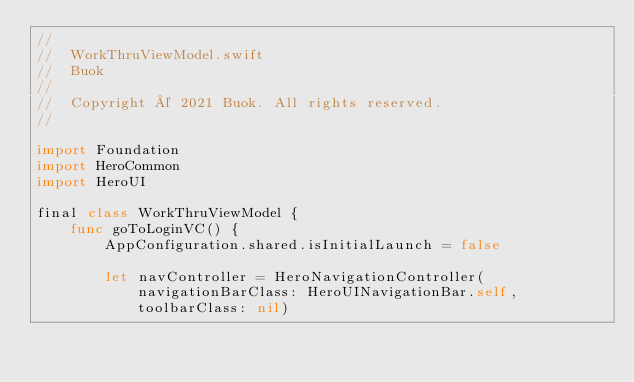<code> <loc_0><loc_0><loc_500><loc_500><_Swift_>//
//  WorkThruViewModel.swift
//  Buok
//
//  Copyright © 2021 Buok. All rights reserved.
//

import Foundation
import HeroCommon
import HeroUI

final class WorkThruViewModel {
    func goToLoginVC() {
        AppConfiguration.shared.isInitialLaunch = false
        
        let navController = HeroNavigationController(navigationBarClass: HeroUINavigationBar.self, toolbarClass: nil)</code> 